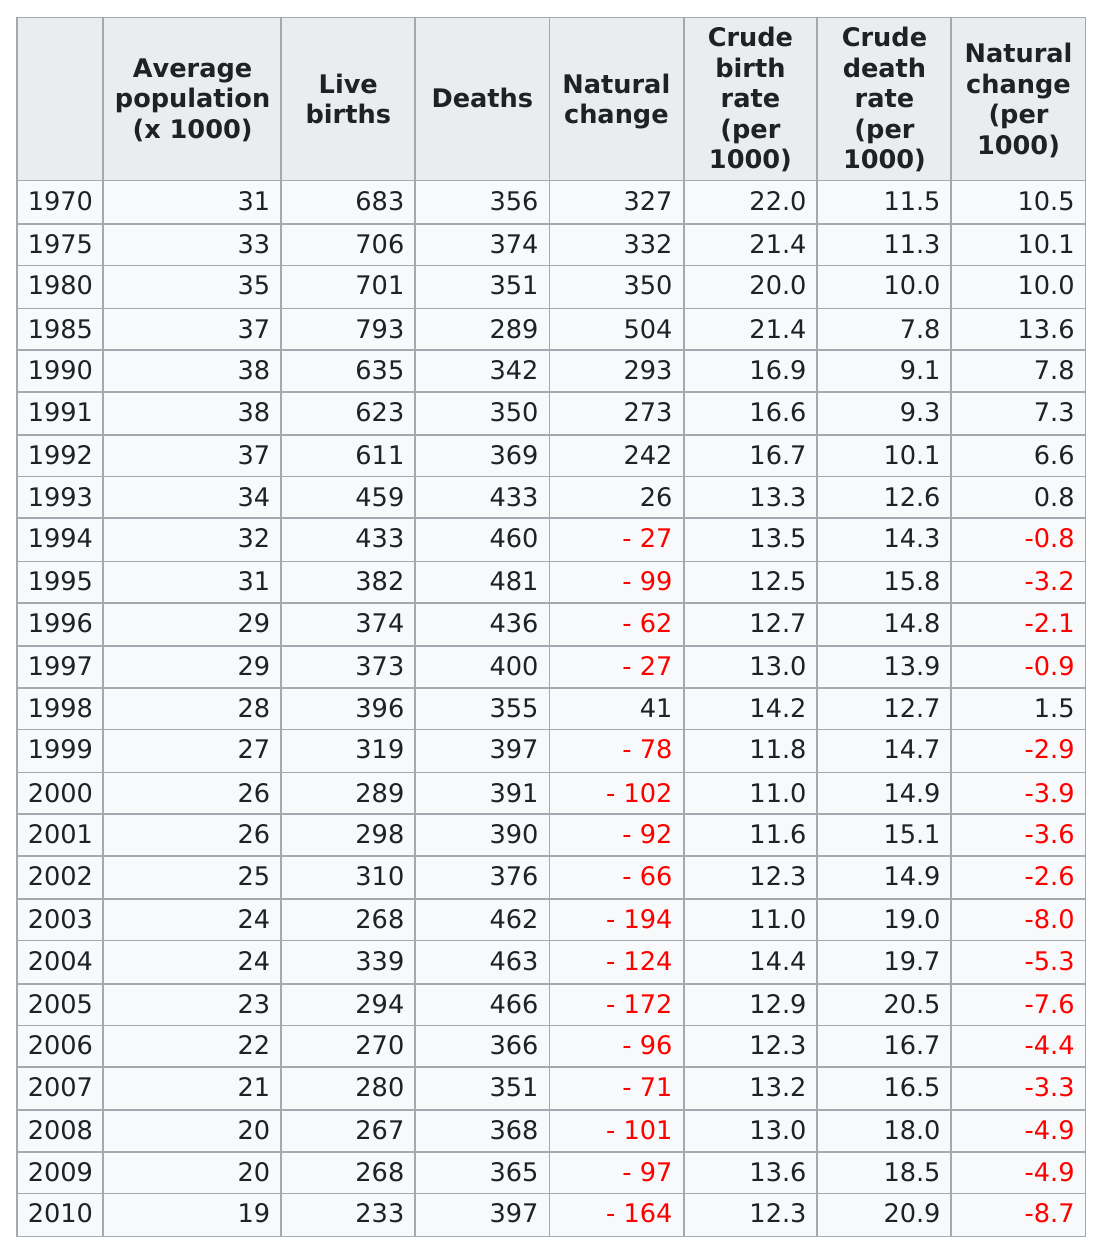Identify some key points in this picture. The total number of natural change in 1980 was 350. In 2002, there were approximately 310 live births. In 2006, there were more deaths than in 1998. The first year that a live birth occurred below 300 was in 2000. In the year 1985, there were the most births. 